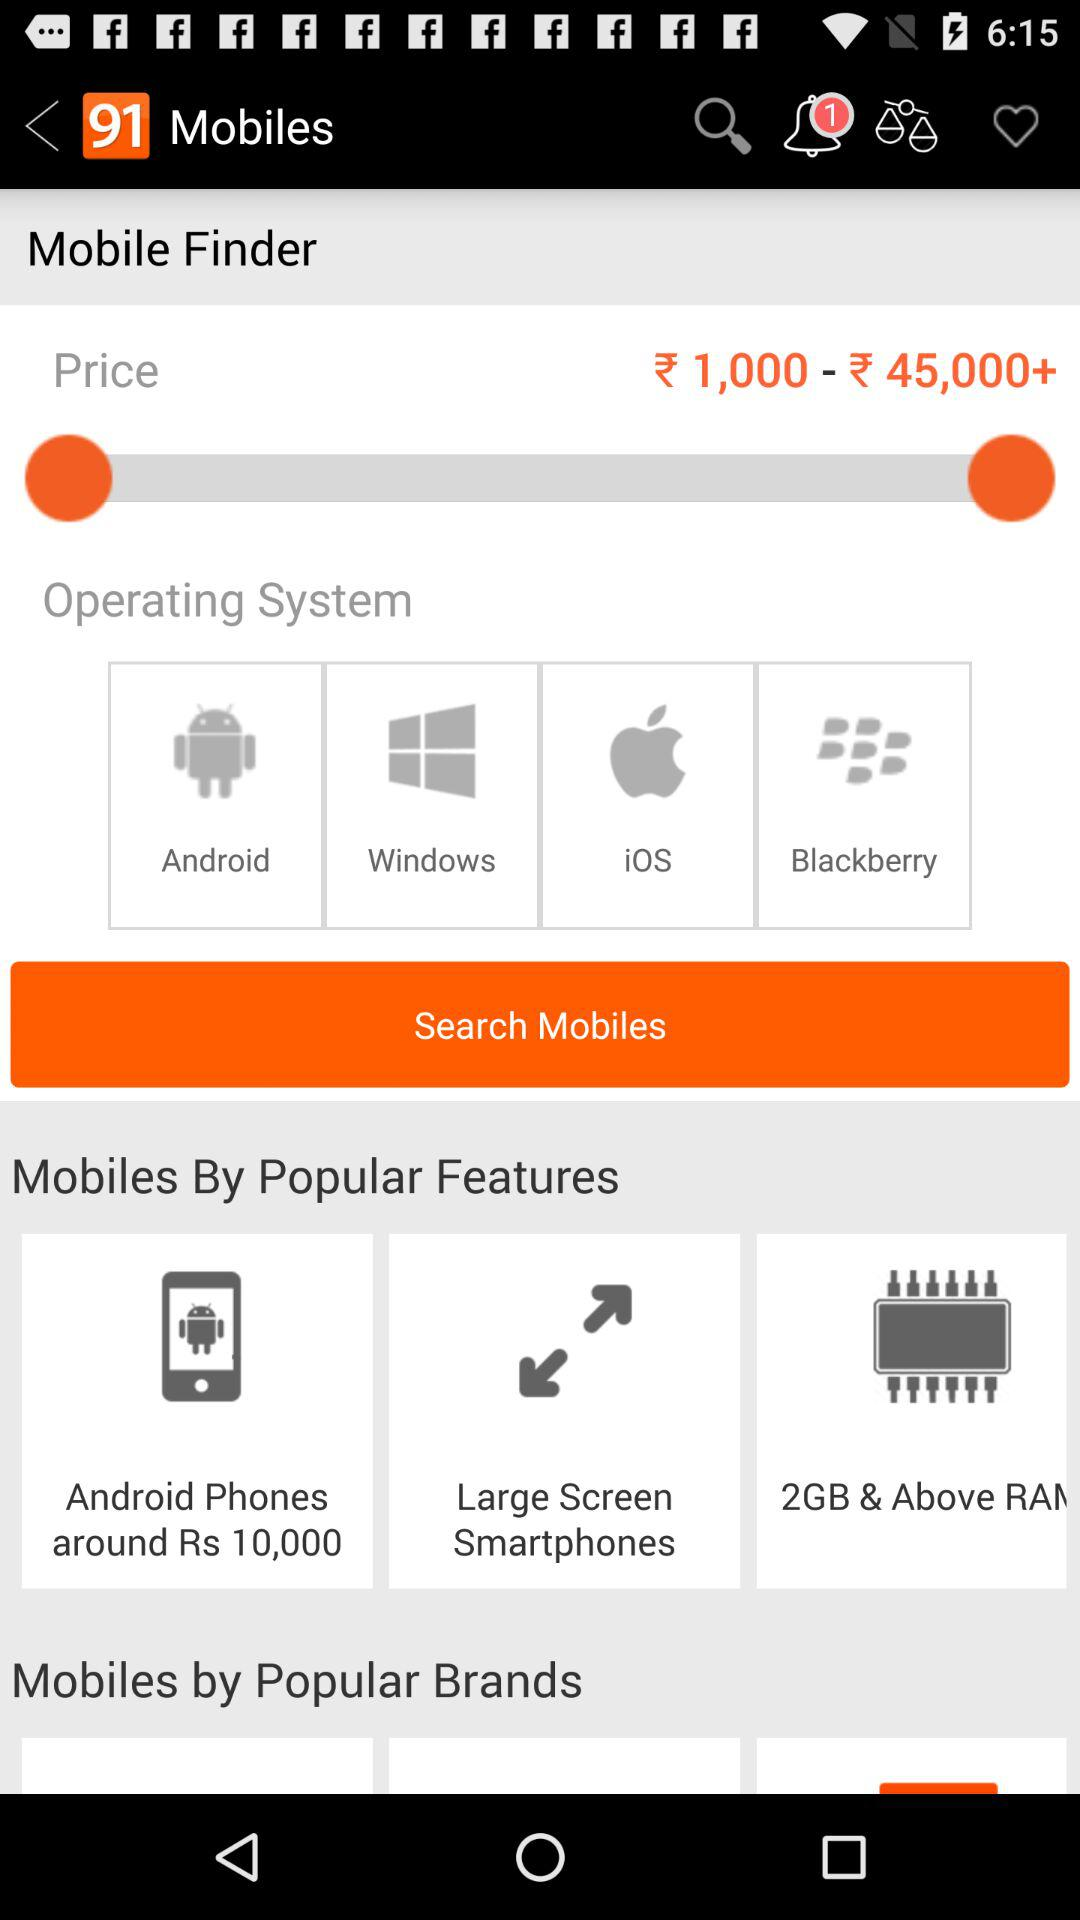What is the app name? The app name is "91mobiles". 